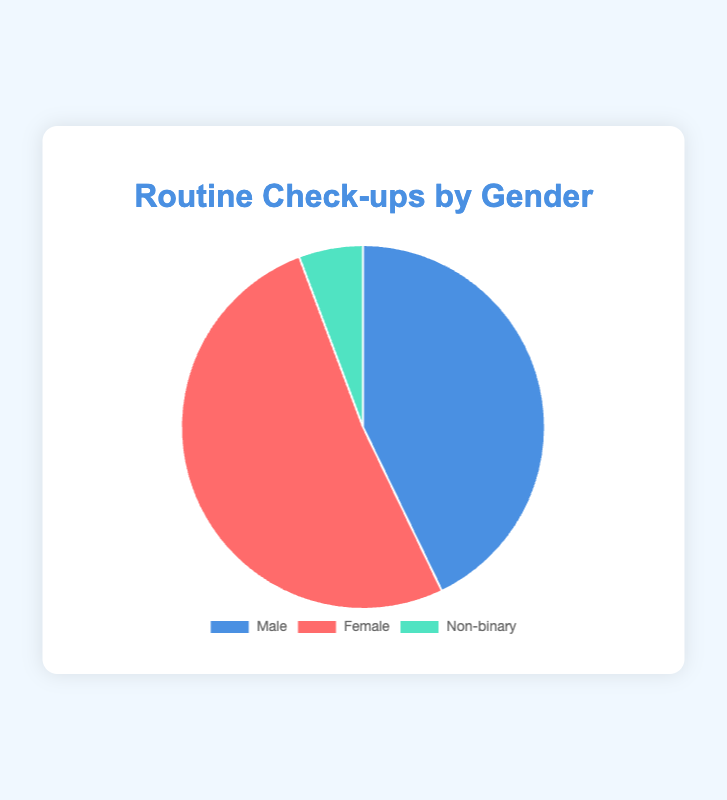What percentage of routine check-ups are for males? The chart shows that 150 check-ups are for males. The total number of check-ups is 150 (males) + 180 (females) + 20 (non-binary) = 350. The percentage is (150/350) * 100 = 42.86%.
Answer: 42.86% Which gender has the highest number of routine check-ups? By comparing the data points, females have 180 check-ups, males have 150, and non-binary individuals have 20. Therefore, females have the highest number.
Answer: Females How many routine check-ups are for non-binary individuals? The chart shows that there are 20 routine check-ups for non-binary individuals.
Answer: 20 What is the difference in the number of check-ups between females and males? The chart indicates 180 check-ups for females and 150 for males. The difference is 180 - 150 = 30.
Answer: 30 What is the total number of routine check-ups represented in the chart? Summing up all the check-ups: 150 (males) + 180 (females) + 20 (non-binary) = 350.
Answer: 350 Which gender's check-ups account for less than 10% of the total? Non-binary individuals have 20 check-ups. The total is 350. The percentage is (20/350) * 100 ≈ 5.71%, which is less than 10%.
Answer: Non-binary By what percentage do female check-ups exceed male check-ups? Female check-ups are 180, and male check-ups are 150. The difference is 180 - 150 = 30. The percentage increase is (30/150) * 100 = 20%.
Answer: 20% What are the colors representing each gender in the pie chart? The pie chart uses blue for males, red for females, and green for non-binary individuals.
Answer: Blue for males, red for females, green for non-binary What proportion of the total check-ups are female check-ups? Female check-ups are 180, out of a total of 350. The proportion is 180/350 ≈ 0.5143.
Answer: 0.5143 How much lower is the number of non-binary check-ups compared to the combined total of male and female check-ups? The non-binary check-ups are 20. The combined male and female check-ups are 150 + 180 = 330. The difference is 330 - 20 = 310.
Answer: 310 